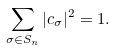<formula> <loc_0><loc_0><loc_500><loc_500>\sum _ { \sigma \in S _ { n } } | c _ { \sigma } | ^ { 2 } = 1 .</formula> 